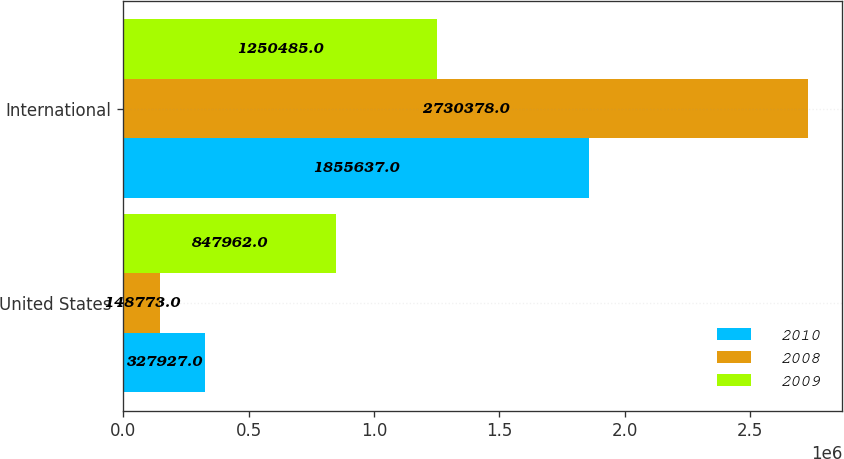<chart> <loc_0><loc_0><loc_500><loc_500><stacked_bar_chart><ecel><fcel>United States<fcel>International<nl><fcel>2010<fcel>327927<fcel>1.85564e+06<nl><fcel>2008<fcel>148773<fcel>2.73038e+06<nl><fcel>2009<fcel>847962<fcel>1.25048e+06<nl></chart> 